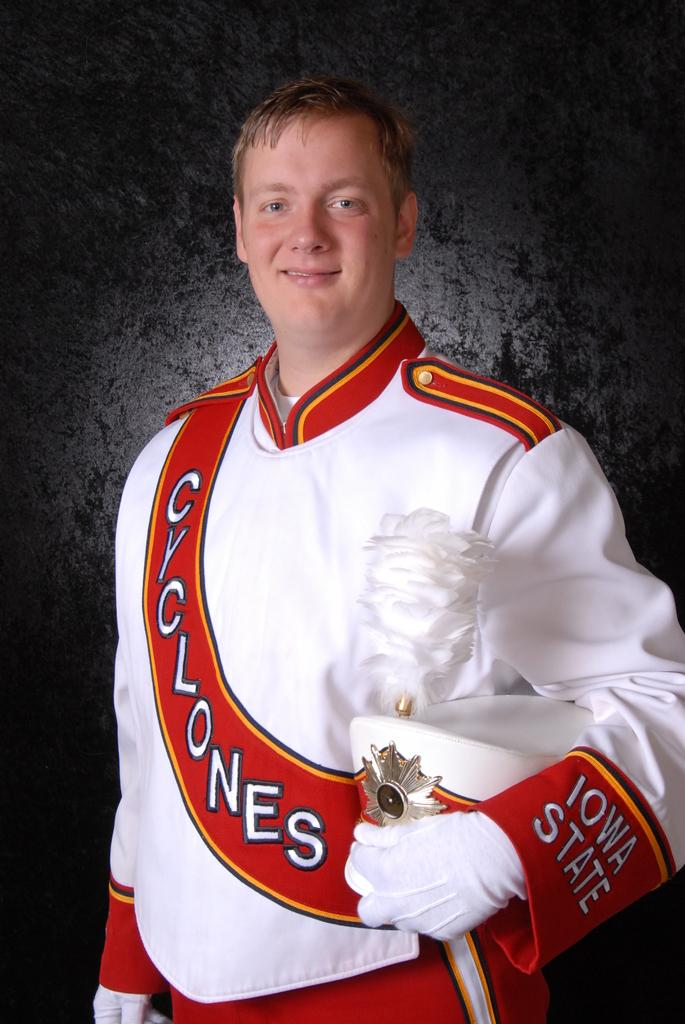<image>
Describe the image concisely. the word cyclones on an outfit that a person is wearing 